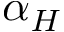Convert formula to latex. <formula><loc_0><loc_0><loc_500><loc_500>\alpha _ { H }</formula> 